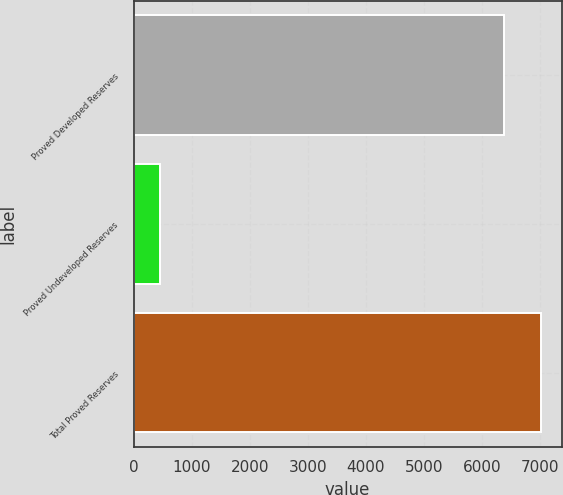Convert chart to OTSL. <chart><loc_0><loc_0><loc_500><loc_500><bar_chart><fcel>Proved Developed Reserves<fcel>Proved Undeveloped Reserves<fcel>Total Proved Reserves<nl><fcel>6382<fcel>459<fcel>7020.2<nl></chart> 